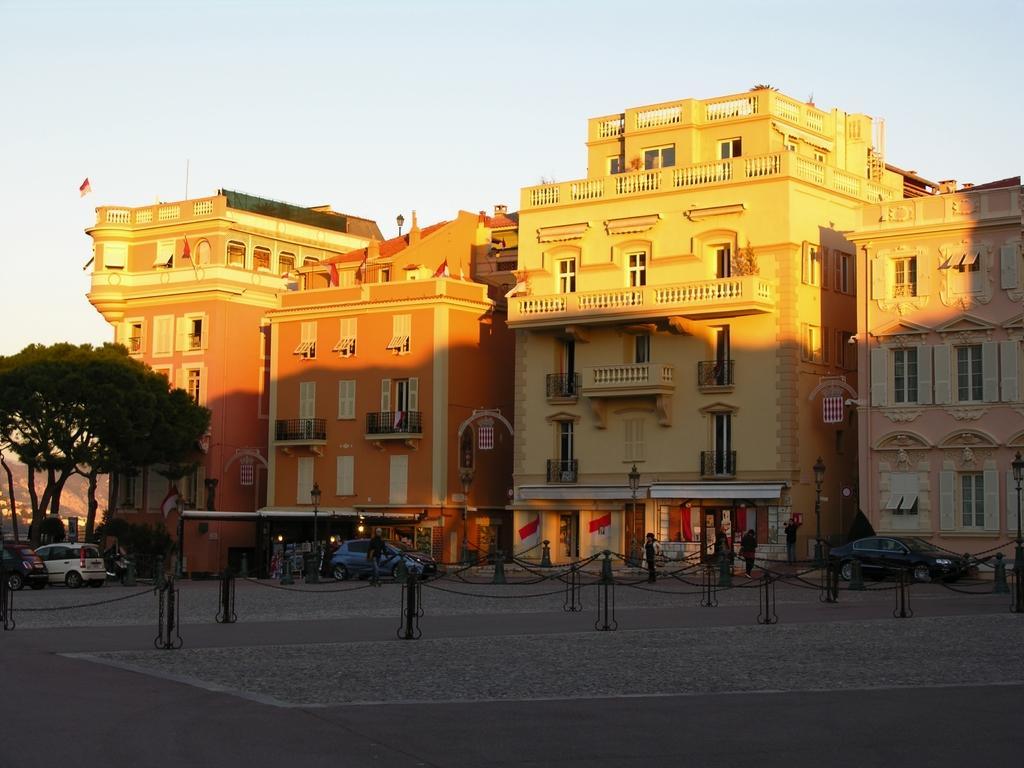Please provide a concise description of this image. In this image we can see some buildings with windows. We can also see a fence, some cars parked aside, lights, street poles, the flags, trees, a group of people standing and the sky which looks cloudy. 